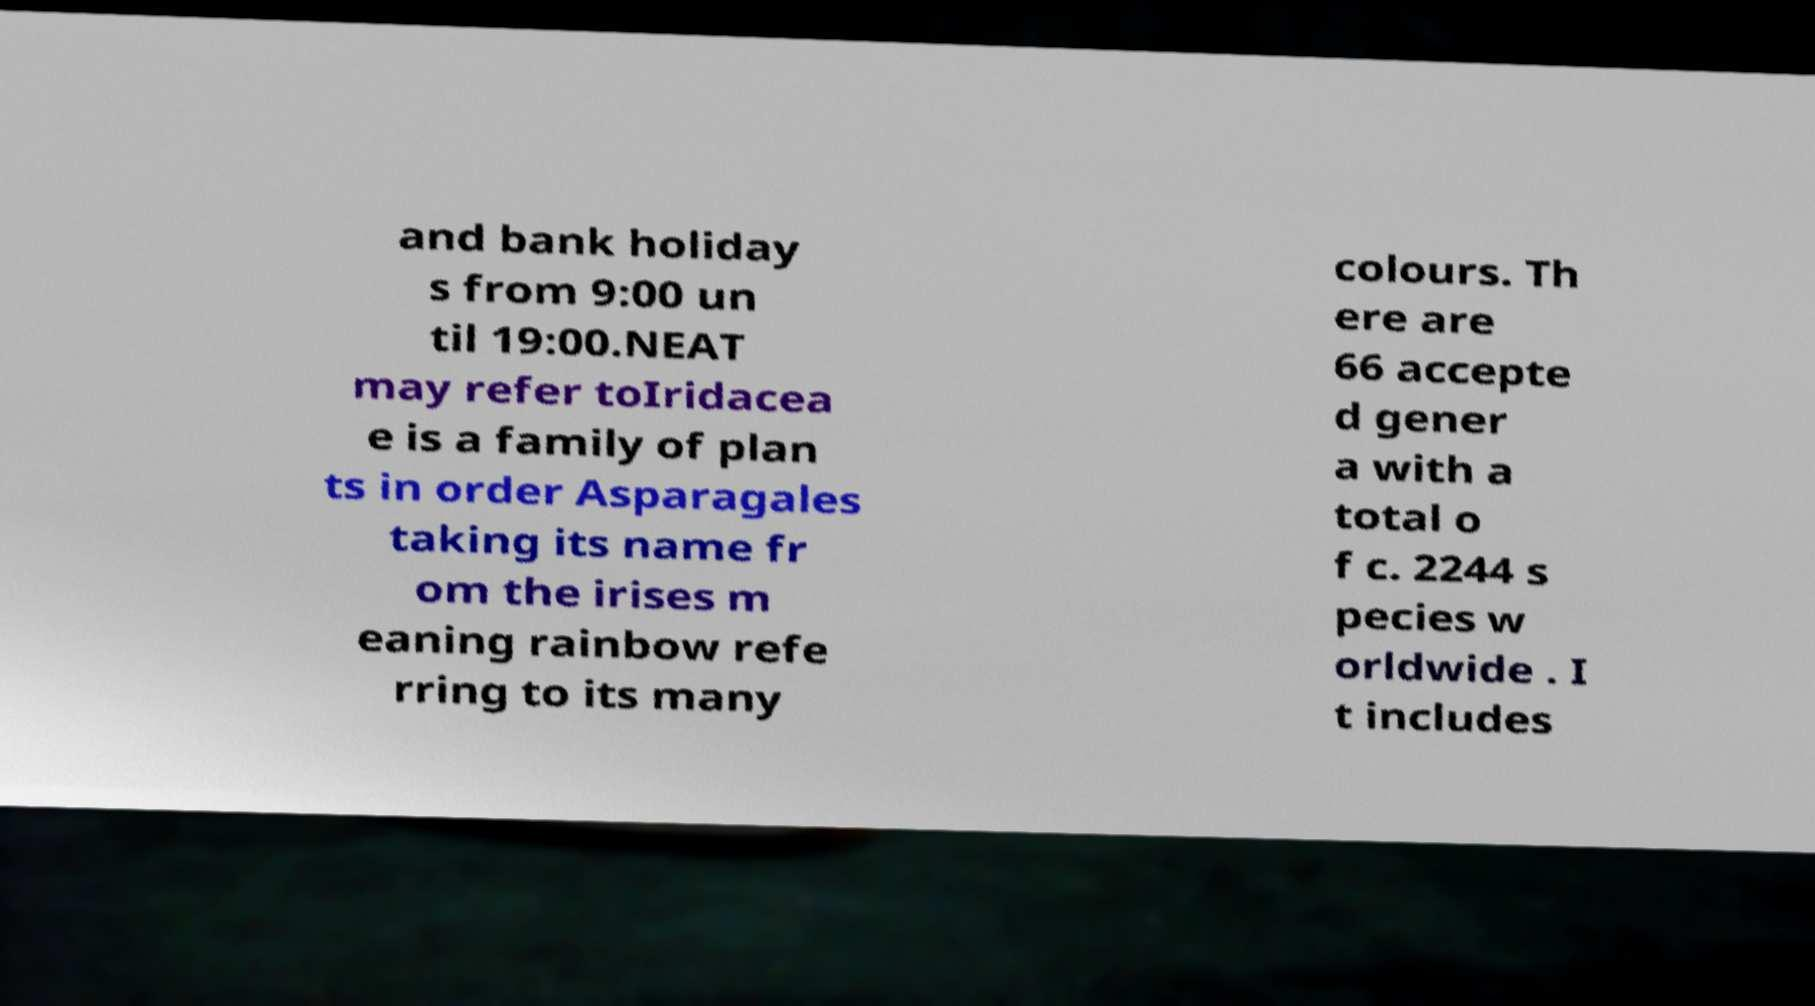Could you extract and type out the text from this image? and bank holiday s from 9:00 un til 19:00.NEAT may refer toIridacea e is a family of plan ts in order Asparagales taking its name fr om the irises m eaning rainbow refe rring to its many colours. Th ere are 66 accepte d gener a with a total o f c. 2244 s pecies w orldwide . I t includes 